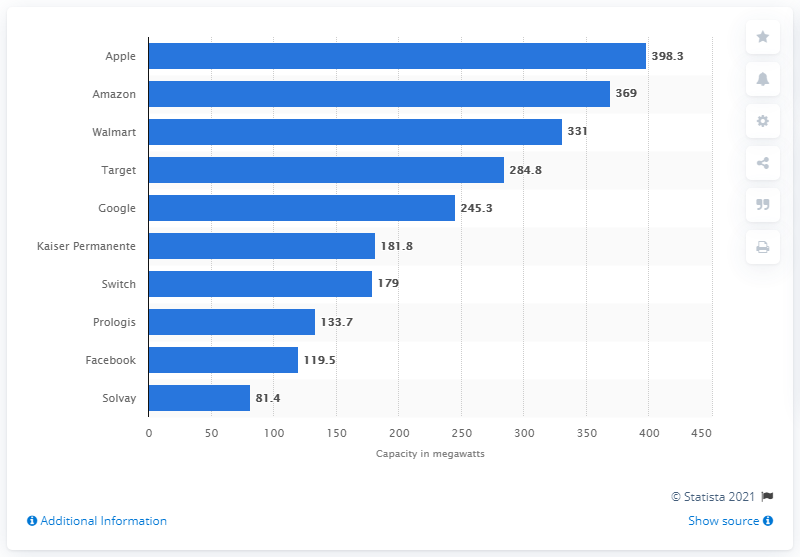Give some essential details in this illustration. Apple has the largest solar energy capacity in the commercial sector. 